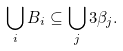Convert formula to latex. <formula><loc_0><loc_0><loc_500><loc_500>\bigcup _ { i } B _ { i } \subseteq \bigcup _ { j } 3 \beta _ { j } .</formula> 